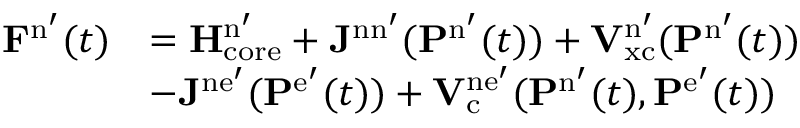<formula> <loc_0><loc_0><loc_500><loc_500>\begin{array} { r l } { F ^ { n ^ { \prime } } ( t ) } & { = H _ { c o r e } ^ { n ^ { \prime } } + J ^ { n n ^ { \prime } } ( P ^ { n ^ { \prime } } ( t ) ) + V _ { x c } ^ { n ^ { \prime } } ( P ^ { n ^ { \prime } } ( t ) ) } \\ & { - J ^ { n e ^ { \prime } } ( P ^ { e ^ { \prime } } ( t ) ) + V _ { c } ^ { n e ^ { \prime } } ( P ^ { n ^ { \prime } } ( t ) , P ^ { e ^ { \prime } } ( t ) ) } \end{array}</formula> 